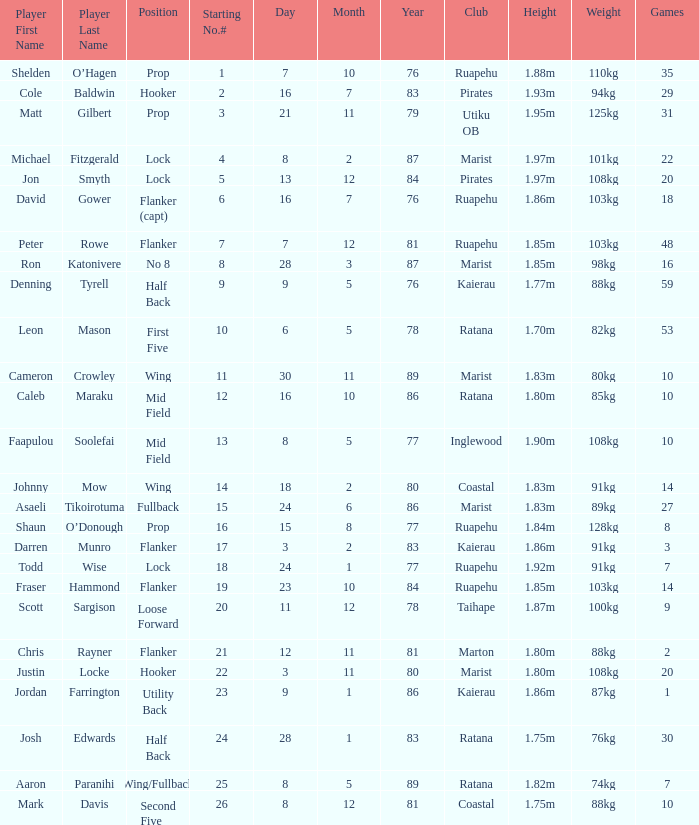How many games involved a player whose height measures 1.92m? 1.0. 